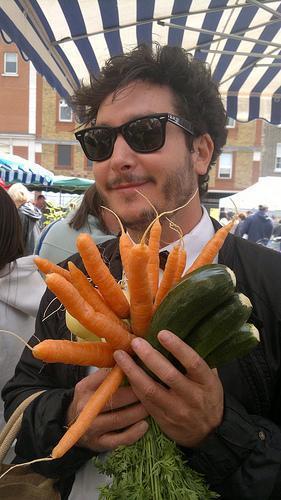How many cucumbers is the man holding?
Give a very brief answer. 3. 